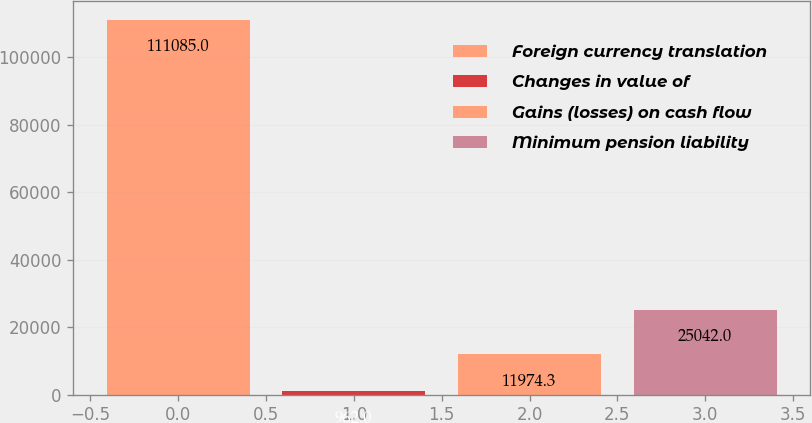<chart> <loc_0><loc_0><loc_500><loc_500><bar_chart><fcel>Foreign currency translation<fcel>Changes in value of<fcel>Gains (losses) on cash flow<fcel>Minimum pension liability<nl><fcel>111085<fcel>962<fcel>11974.3<fcel>25042<nl></chart> 